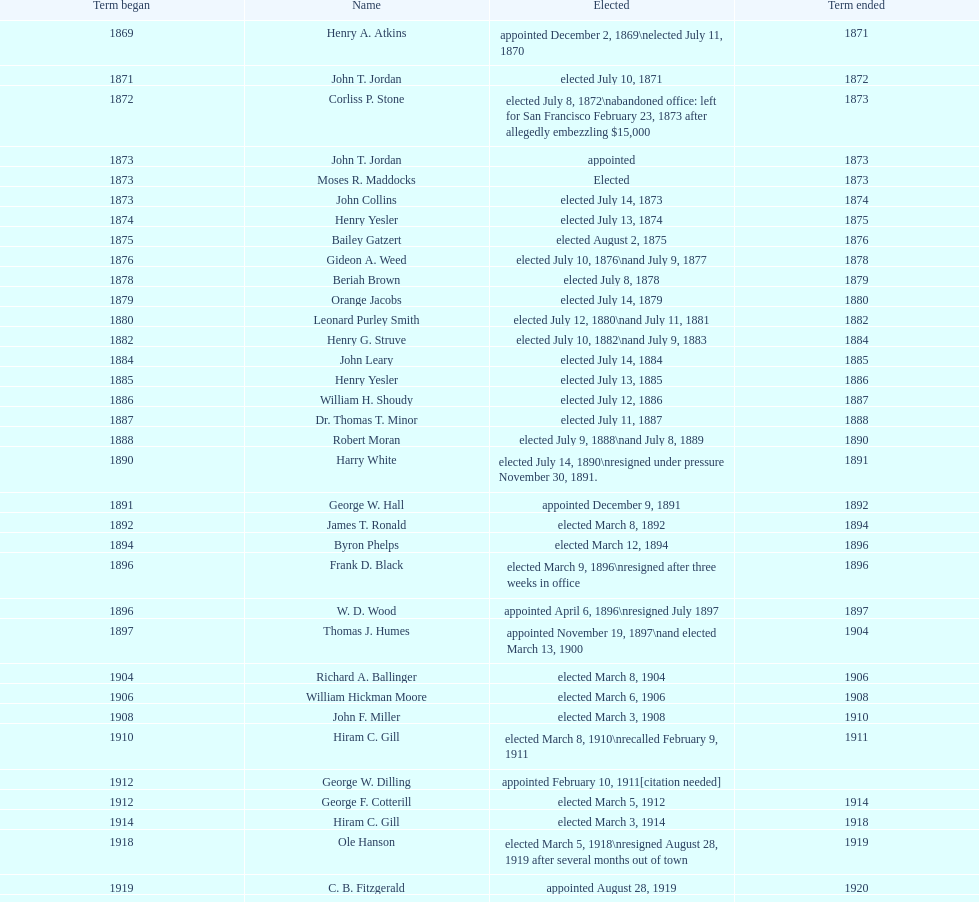Who was the first mayor in the 1900's? Richard A. Ballinger. 